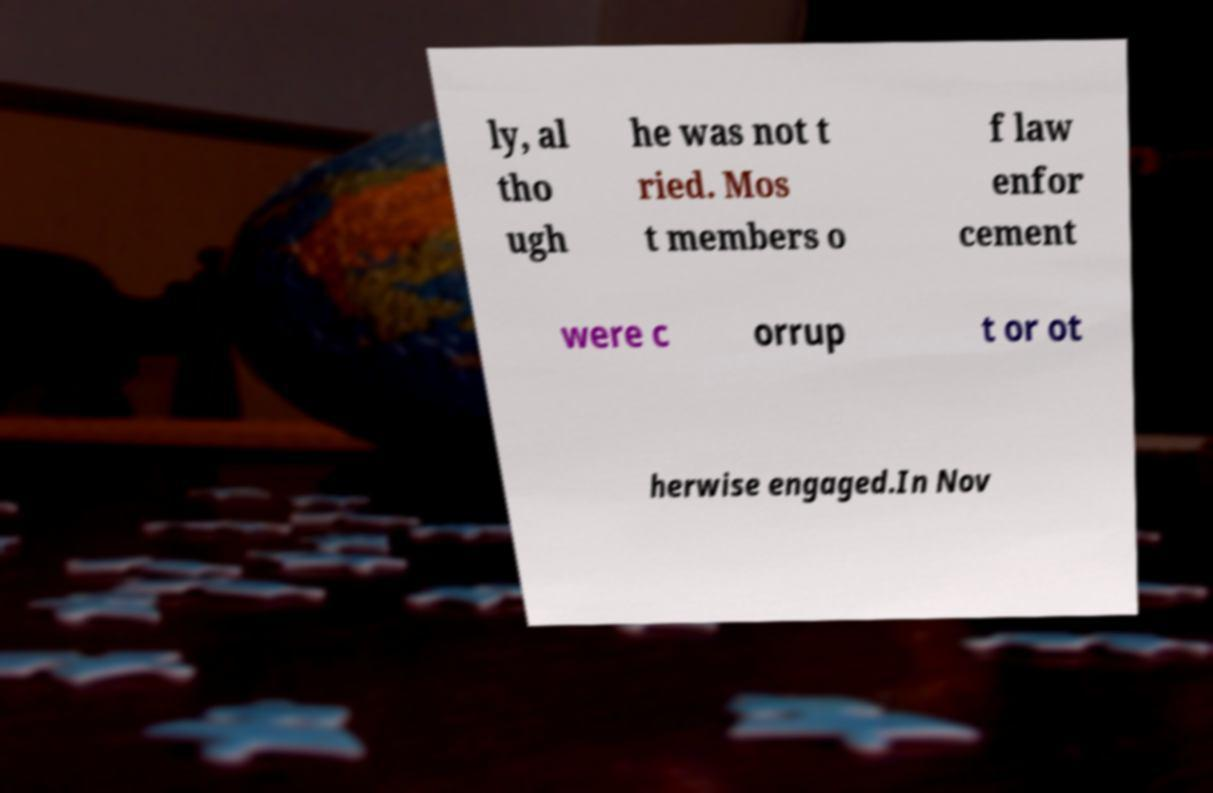What messages or text are displayed in this image? I need them in a readable, typed format. ly, al tho ugh he was not t ried. Mos t members o f law enfor cement were c orrup t or ot herwise engaged.In Nov 